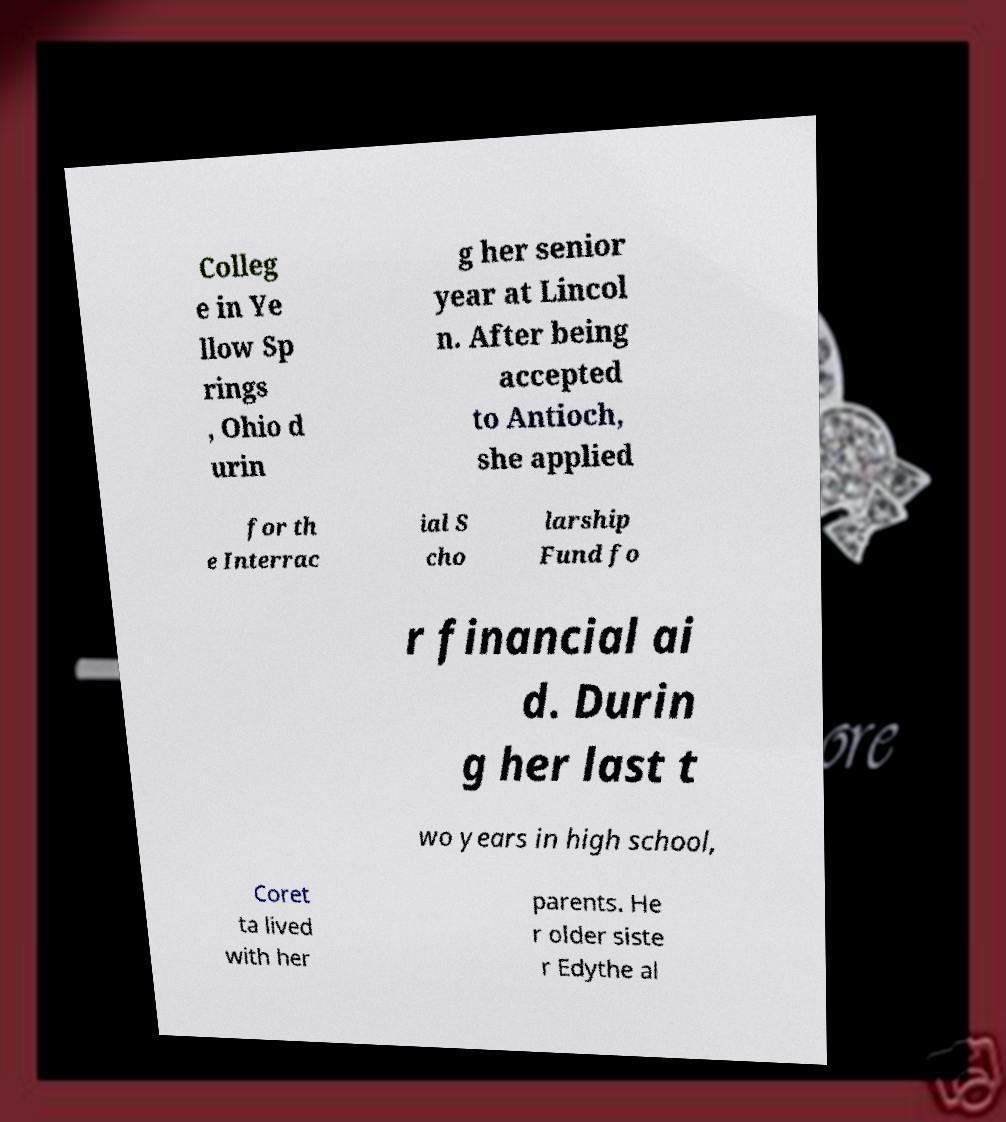I need the written content from this picture converted into text. Can you do that? Colleg e in Ye llow Sp rings , Ohio d urin g her senior year at Lincol n. After being accepted to Antioch, she applied for th e Interrac ial S cho larship Fund fo r financial ai d. Durin g her last t wo years in high school, Coret ta lived with her parents. He r older siste r Edythe al 